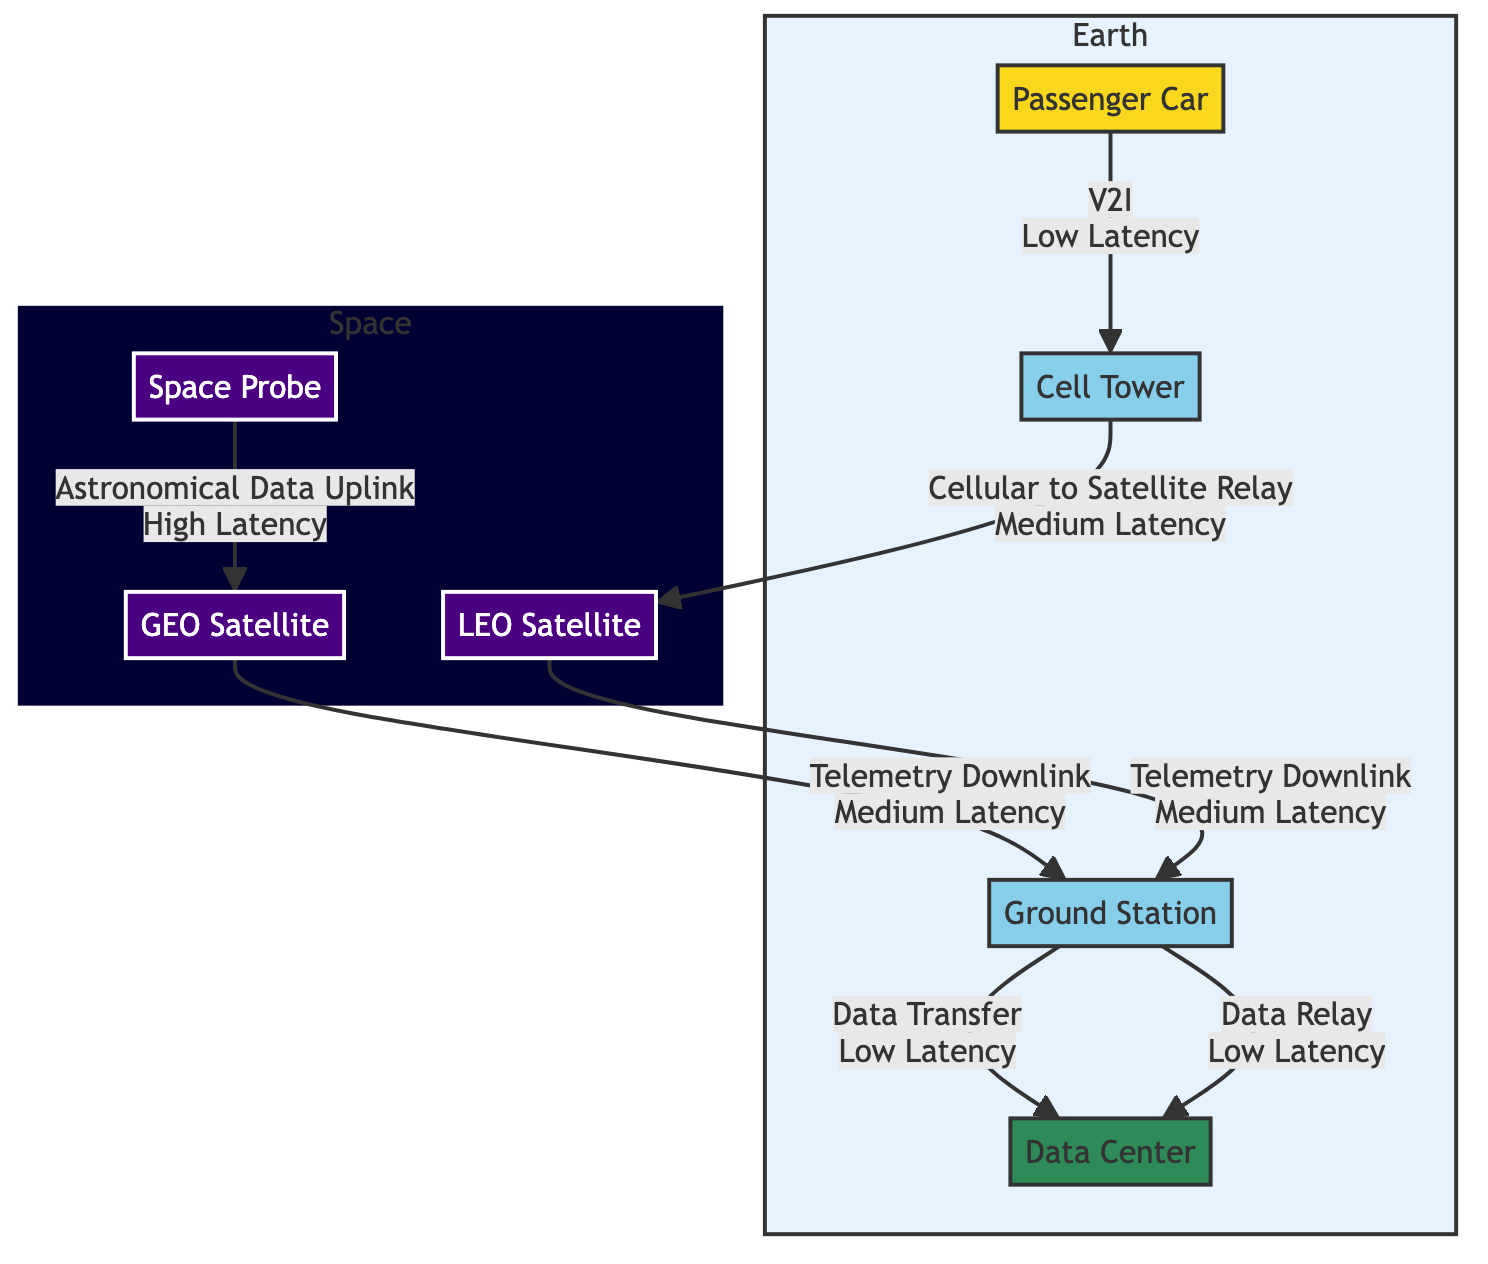What is the first node in the vehicle connectivity network? The vehicle connectivity network begins with the "Passenger Car" node, which is the first and only vehicle node depicted in the diagram.
Answer: Passenger Car How many communication methods are represented in the diagram? The diagram showcases four communication methods: Vehicle-to-Infrastructure, Cellular to Satellite Relay, Telemetry Downlink, and Data Transfer.
Answer: Four What type of satellite is shown as connected to the cell tower? The satellite that is directly connected to the cell tower is a "LEO Satellite," indicating a low Earth orbit connection for communication.
Answer: LEO Satellite Which node has the highest latency in the data flow? The node representing the space probe has the highest latency due to its designated connection labeled "Astronomical Data Uplink." This indicates a slower transmission due to the distance and technology involved.
Answer: Space Probe How does the Ground Station connect to the Data Center? The Ground Station connects to the Data Center via "Data Transfer" which is specified as having low latency, indicating efficient communication between the two nodes.
Answer: Data Transfer What are the two types of satellites depicted in the space section? The two types of satellites illustrated are "LEO Satellite" (Low Earth Orbit) and "GEO Satellite" (Geostationary Orbit), showing a distinction based on their orbital positions.
Answer: LEO Satellite and GEO Satellite Which node corresponds to the medium latency connection? The connection labeled as "Cellular to Satellite Relay" has a medium latency, indicating that it falls between low and high latency in the communication chain.
Answer: Cellular to Satellite Relay What is the relationship between the Space Probe and GEO Satellite? The Space Probe connects to the GEO Satellite through "Telemetry Downlink," indicating a data flow from the probe to the satellite, which involves medium latency as noted in the diagram.
Answer: Telemetry Downlink How many nodes are in the Earth subgraph? The Earth subgraph consists of four nodes: Passenger Car, Cell Tower, Ground Station, and Data Center, presenting a comprehensive view of terrestrial connectivity.
Answer: Four 